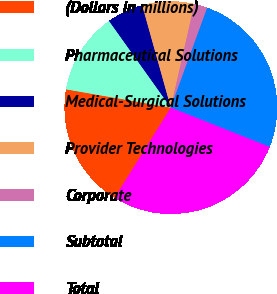Convert chart to OTSL. <chart><loc_0><loc_0><loc_500><loc_500><pie_chart><fcel>(Dollars in millions)<fcel>Pharmaceutical Solutions<fcel>Medical-Surgical Solutions<fcel>Provider Technologies<fcel>Corporate<fcel>Subtotal<fcel>Total<nl><fcel>18.89%<fcel>12.39%<fcel>5.51%<fcel>7.9%<fcel>2.01%<fcel>25.46%<fcel>27.85%<nl></chart> 